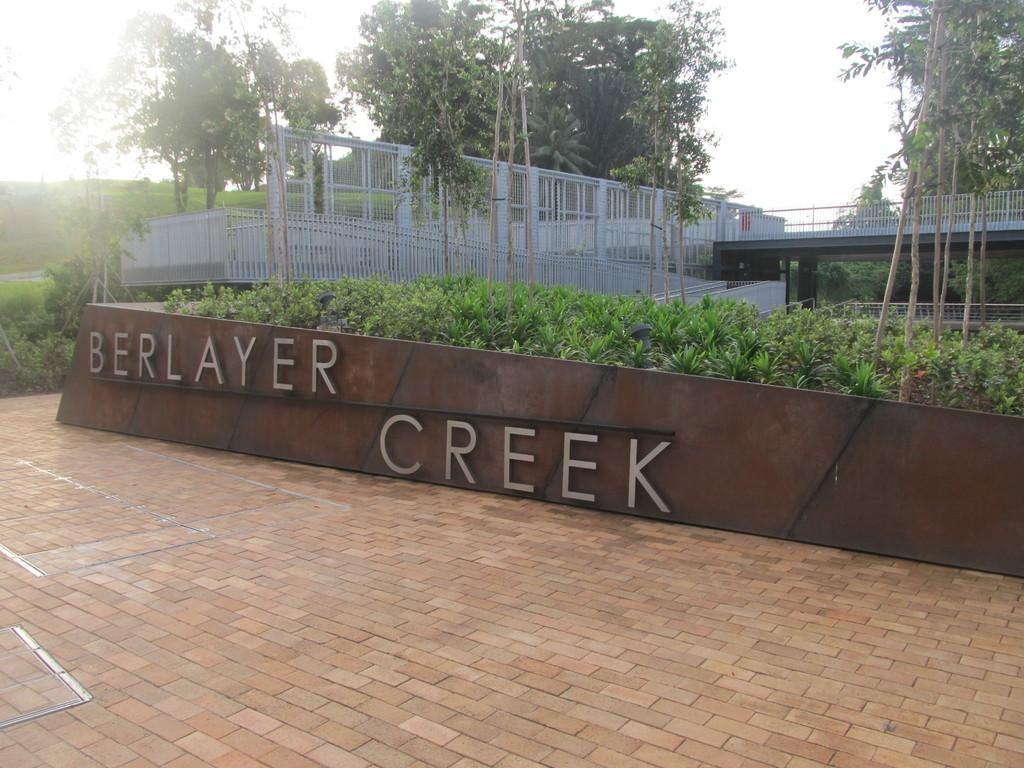What is present on the wall in the image? There is writing on the wall in the image. What can be seen behind the wall? There are plants, a fence, trees, and the sky visible behind the wall. Can you describe the plants behind the wall? The plants behind the wall are not specified, but they are present. What type of structure is the fence behind the wall? The type of fence is not specified in the image. What type of pain is the person experiencing in the image? There is no person present in the image, and therefore no indication of any pain being experienced. 